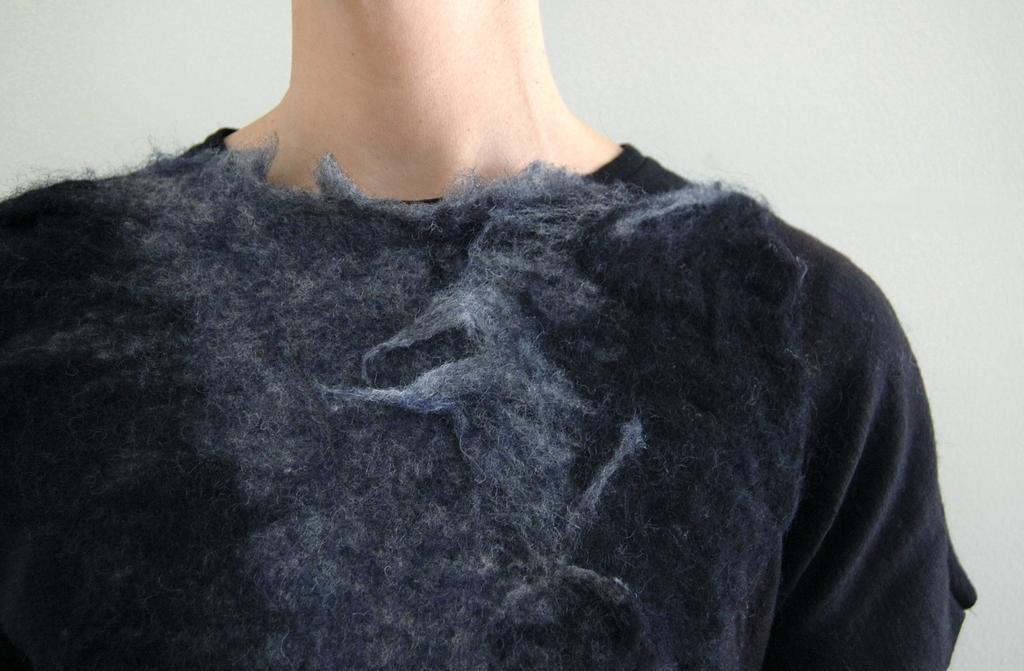Describe this image in one or two sentences. In this picture, we can see a person in black T-shirt is partially covered, and we can see the wall. 